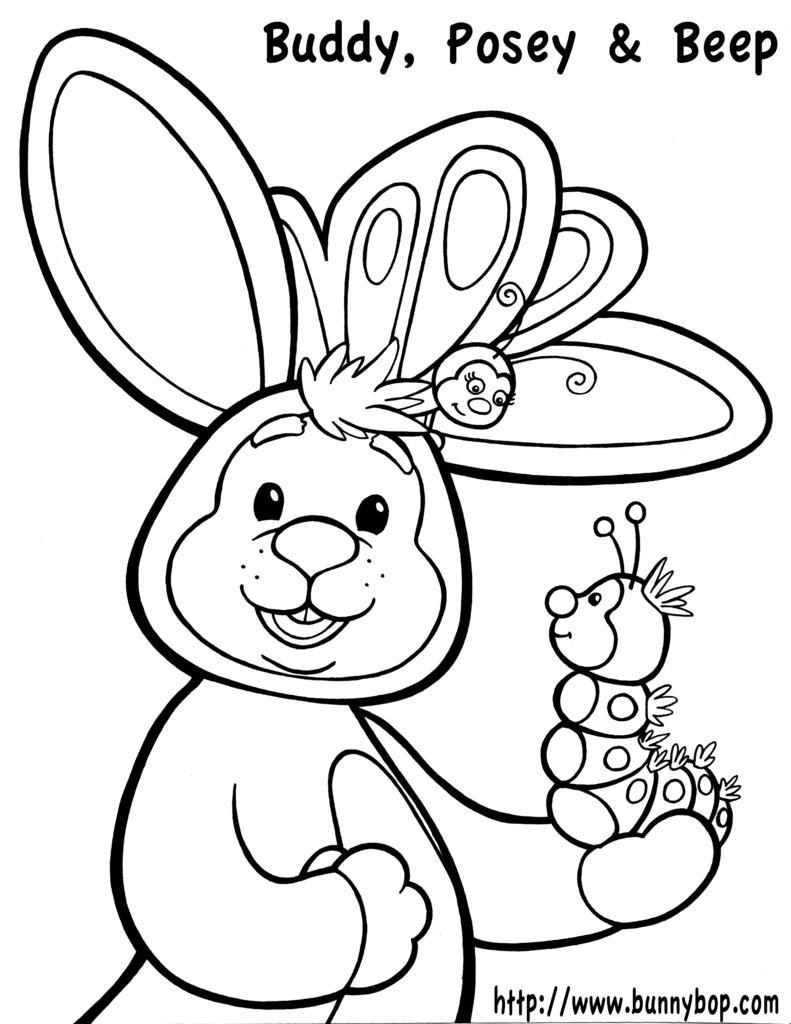Could you give a brief overview of what you see in this image? This is a sketch. In this image we can see the cartoon pictures and text. 